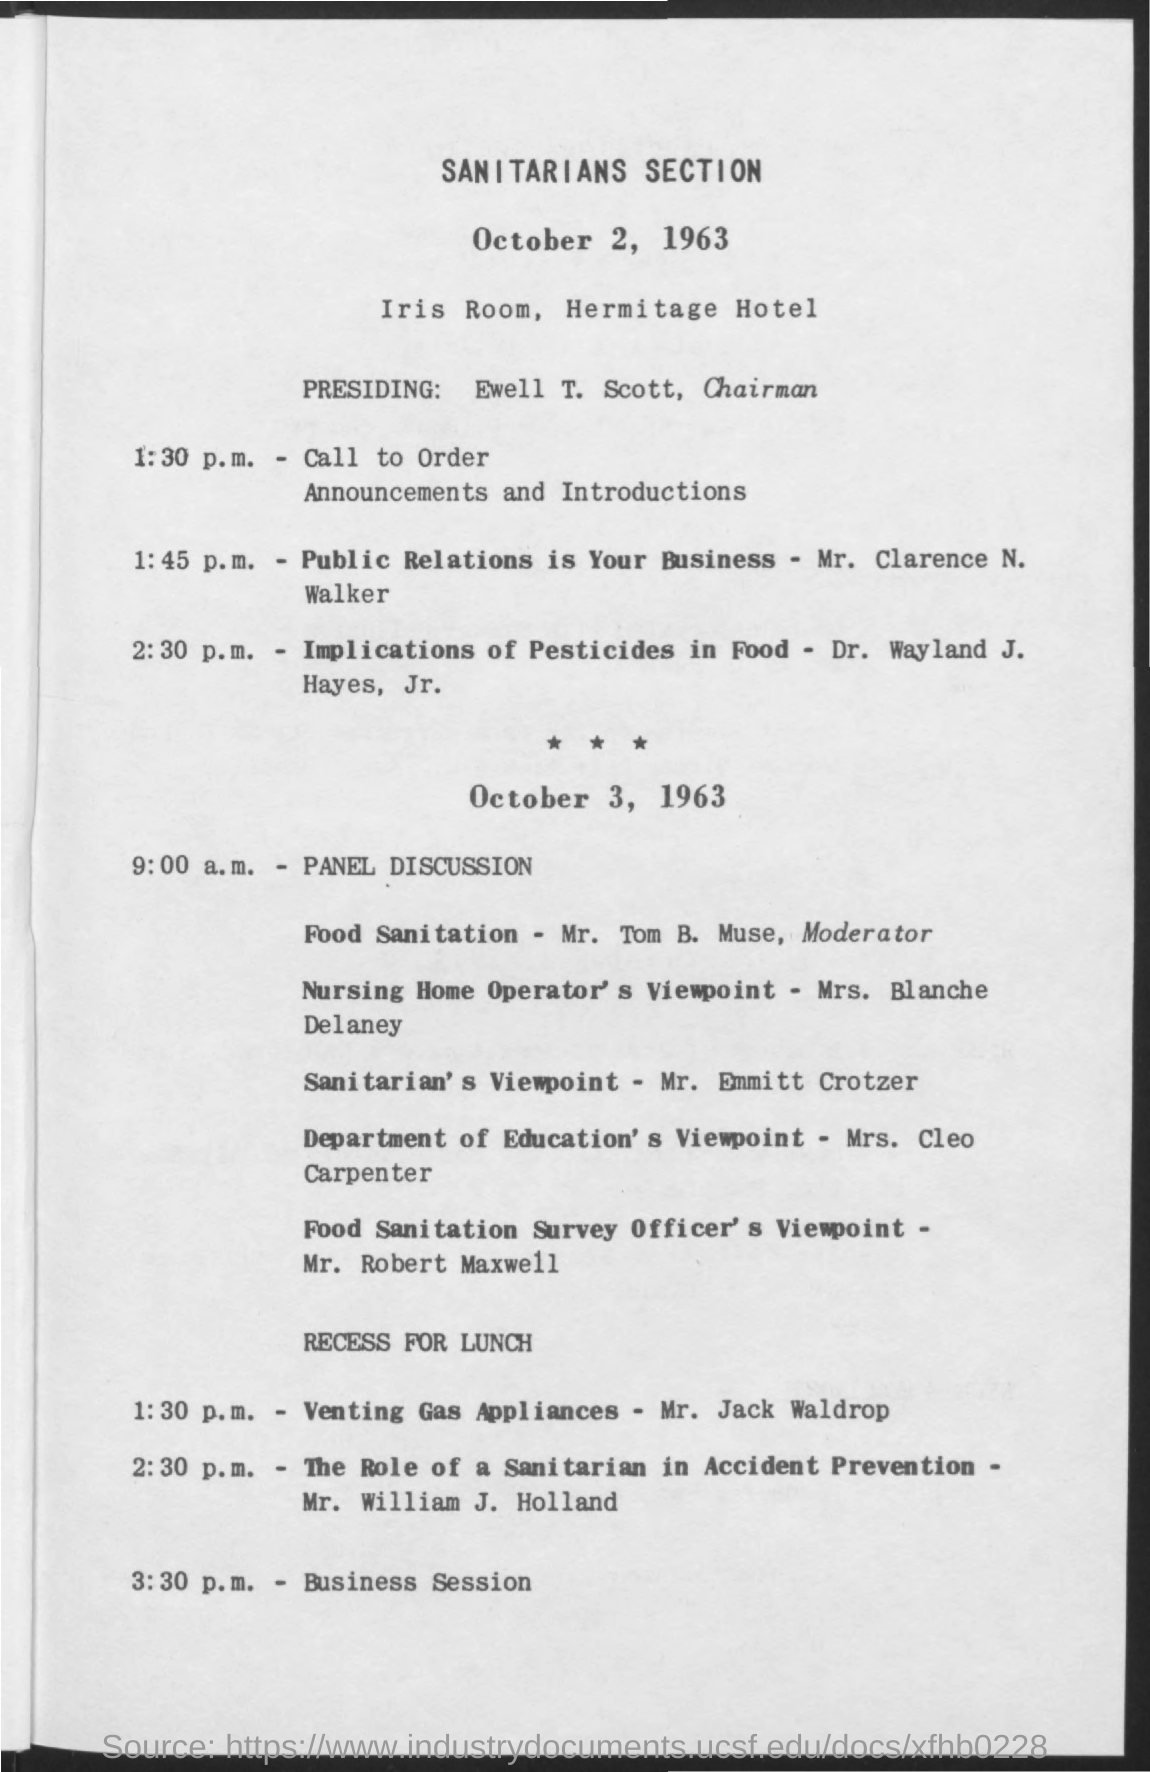Can you tell me something about the location of the event? The event took place at the Iris Room, which is located within the Hermitage Hotel. This hotel might have been chosen for its facilities and the capacity to host such meetings, suggesting importance and possibly a central location convenient for the attendees. 